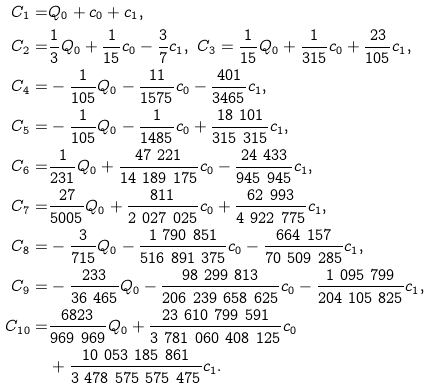<formula> <loc_0><loc_0><loc_500><loc_500>C _ { 1 } = & Q _ { 0 } + c _ { 0 } + c _ { 1 } , \\ C _ { 2 } = & \frac { 1 } { 3 } Q _ { 0 } + \frac { 1 } { 1 5 } c _ { 0 } - \frac { 3 } { 7 } c _ { 1 } , \ C _ { 3 } = \frac { 1 } { 1 5 } Q _ { 0 } + \frac { 1 } { 3 1 5 } c _ { 0 } + \frac { 2 3 } { 1 0 5 } c _ { 1 } , \\ C _ { 4 } = & - \frac { 1 } { 1 0 5 } Q _ { 0 } - \frac { 1 1 } { 1 5 7 5 } c _ { 0 } - \frac { 4 0 1 } { 3 4 6 5 } c _ { 1 } , \\ C _ { 5 } = & - \frac { 1 } { 1 0 5 } Q _ { 0 } - \frac { 1 } { 1 4 8 5 } c _ { 0 } + \frac { 1 8 \ 1 0 1 } { 3 1 5 \ 3 1 5 } c _ { 1 } , \\ C _ { 6 } = & \frac { 1 } { 2 3 1 } Q _ { 0 } + \frac { 4 7 \ 2 2 1 } { 1 4 \ 1 8 9 \ 1 7 5 } c _ { 0 } - \frac { 2 4 \ 4 3 3 } { 9 4 5 \ 9 4 5 } c _ { 1 } , \\ C _ { 7 } = & \frac { 2 7 } { 5 0 0 5 } Q _ { 0 } + \frac { 8 1 1 } { 2 \ 0 2 7 \ 0 2 5 } c _ { 0 } + \frac { 6 2 \ 9 9 3 } { 4 \ 9 2 2 \ 7 7 5 } c _ { 1 } , \\ C _ { 8 } = & - \frac { 3 } { 7 1 5 } Q _ { 0 } - \frac { 1 \ 7 9 0 \ 8 5 1 } { 5 1 6 \ 8 9 1 \ 3 7 5 } c _ { 0 } - \frac { 6 6 4 \ 1 5 7 } { 7 0 \ 5 0 9 \ 2 8 5 } c _ { 1 } , \\ C _ { 9 } = & - \frac { 2 3 3 } { 3 6 \ 4 6 5 } Q _ { 0 } - \frac { 9 8 \ 2 9 9 \ 8 1 3 } { 2 0 6 \ 2 3 9 \ 6 5 8 \ 6 2 5 } c _ { 0 } - \frac { 1 \ 0 9 5 \ 7 9 9 } { 2 0 4 \ 1 0 5 \ 8 2 5 } c _ { 1 } , \\ C _ { 1 0 } = & \frac { 6 8 2 3 } { 9 6 9 \ 9 6 9 } Q _ { 0 } + \frac { 2 3 \ 6 1 0 \ 7 9 9 \ 5 9 1 } { 3 \ 7 8 1 \ 0 6 0 \ 4 0 8 \ 1 2 5 } c _ { 0 } \\ & + \frac { 1 0 \ 0 5 3 \ 1 8 5 \ 8 6 1 } { 3 \ 4 7 8 \ 5 7 5 \ 5 7 5 \ 4 7 5 } c _ { 1 } .</formula> 